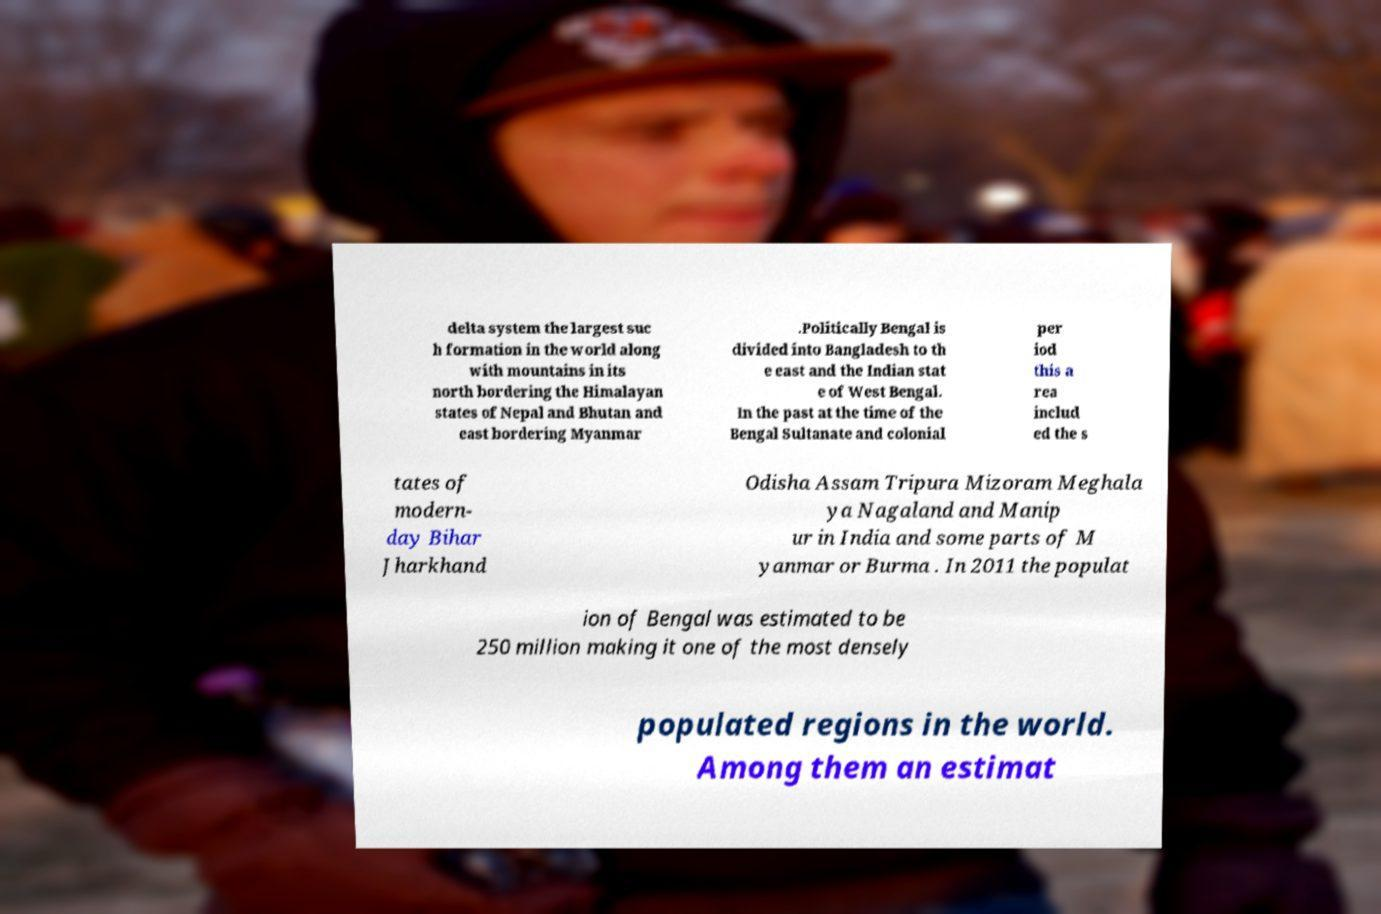Could you extract and type out the text from this image? delta system the largest suc h formation in the world along with mountains in its north bordering the Himalayan states of Nepal and Bhutan and east bordering Myanmar .Politically Bengal is divided into Bangladesh to th e east and the Indian stat e of West Bengal. In the past at the time of the Bengal Sultanate and colonial per iod this a rea includ ed the s tates of modern- day Bihar Jharkhand Odisha Assam Tripura Mizoram Meghala ya Nagaland and Manip ur in India and some parts of M yanmar or Burma . In 2011 the populat ion of Bengal was estimated to be 250 million making it one of the most densely populated regions in the world. Among them an estimat 